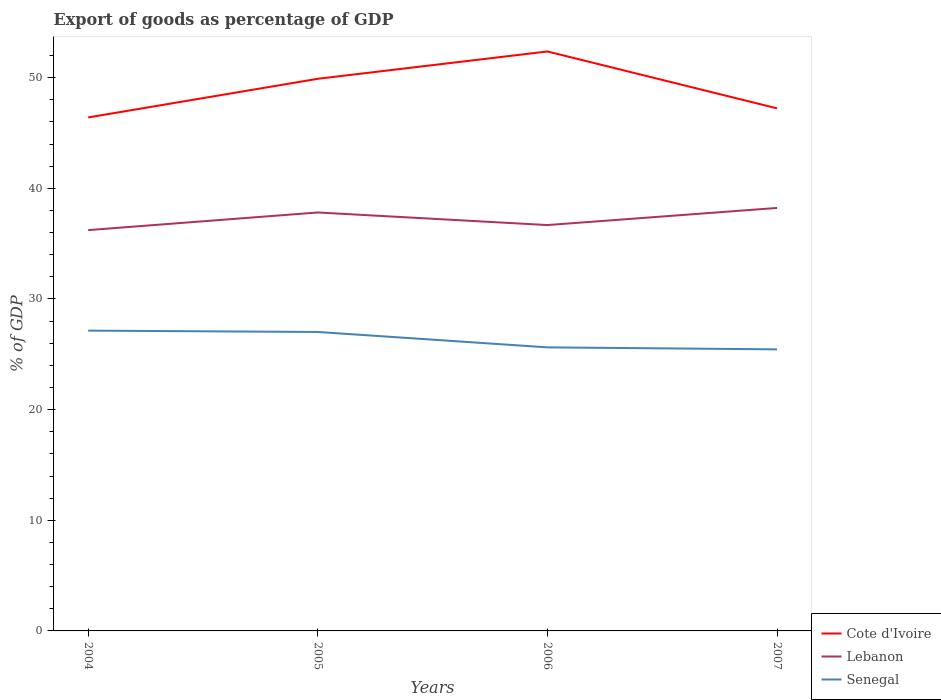Does the line corresponding to Cote d'Ivoire intersect with the line corresponding to Lebanon?
Give a very brief answer. No. Is the number of lines equal to the number of legend labels?
Offer a terse response. Yes. Across all years, what is the maximum export of goods as percentage of GDP in Lebanon?
Make the answer very short. 36.22. What is the total export of goods as percentage of GDP in Senegal in the graph?
Provide a short and direct response. 0.12. What is the difference between the highest and the second highest export of goods as percentage of GDP in Cote d'Ivoire?
Your answer should be very brief. 5.96. What is the difference between the highest and the lowest export of goods as percentage of GDP in Senegal?
Give a very brief answer. 2. Is the export of goods as percentage of GDP in Senegal strictly greater than the export of goods as percentage of GDP in Cote d'Ivoire over the years?
Your response must be concise. Yes. Does the graph contain any zero values?
Provide a short and direct response. No. Where does the legend appear in the graph?
Offer a very short reply. Bottom right. How many legend labels are there?
Make the answer very short. 3. What is the title of the graph?
Your answer should be very brief. Export of goods as percentage of GDP. What is the label or title of the X-axis?
Your answer should be very brief. Years. What is the label or title of the Y-axis?
Provide a short and direct response. % of GDP. What is the % of GDP in Cote d'Ivoire in 2004?
Provide a succinct answer. 46.41. What is the % of GDP of Lebanon in 2004?
Provide a succinct answer. 36.22. What is the % of GDP in Senegal in 2004?
Your answer should be compact. 27.14. What is the % of GDP in Cote d'Ivoire in 2005?
Provide a succinct answer. 49.9. What is the % of GDP in Lebanon in 2005?
Your response must be concise. 37.82. What is the % of GDP in Senegal in 2005?
Keep it short and to the point. 27.02. What is the % of GDP of Cote d'Ivoire in 2006?
Offer a terse response. 52.37. What is the % of GDP in Lebanon in 2006?
Offer a terse response. 36.68. What is the % of GDP in Senegal in 2006?
Offer a terse response. 25.63. What is the % of GDP in Cote d'Ivoire in 2007?
Provide a succinct answer. 47.23. What is the % of GDP of Lebanon in 2007?
Make the answer very short. 38.23. What is the % of GDP in Senegal in 2007?
Your answer should be very brief. 25.45. Across all years, what is the maximum % of GDP in Cote d'Ivoire?
Make the answer very short. 52.37. Across all years, what is the maximum % of GDP in Lebanon?
Provide a short and direct response. 38.23. Across all years, what is the maximum % of GDP in Senegal?
Keep it short and to the point. 27.14. Across all years, what is the minimum % of GDP of Cote d'Ivoire?
Offer a terse response. 46.41. Across all years, what is the minimum % of GDP in Lebanon?
Your answer should be compact. 36.22. Across all years, what is the minimum % of GDP of Senegal?
Your answer should be compact. 25.45. What is the total % of GDP in Cote d'Ivoire in the graph?
Provide a short and direct response. 195.9. What is the total % of GDP of Lebanon in the graph?
Your answer should be compact. 148.95. What is the total % of GDP in Senegal in the graph?
Your response must be concise. 105.23. What is the difference between the % of GDP in Cote d'Ivoire in 2004 and that in 2005?
Ensure brevity in your answer.  -3.49. What is the difference between the % of GDP in Lebanon in 2004 and that in 2005?
Make the answer very short. -1.59. What is the difference between the % of GDP of Senegal in 2004 and that in 2005?
Your answer should be very brief. 0.12. What is the difference between the % of GDP in Cote d'Ivoire in 2004 and that in 2006?
Make the answer very short. -5.96. What is the difference between the % of GDP of Lebanon in 2004 and that in 2006?
Keep it short and to the point. -0.46. What is the difference between the % of GDP of Senegal in 2004 and that in 2006?
Your answer should be very brief. 1.51. What is the difference between the % of GDP in Cote d'Ivoire in 2004 and that in 2007?
Ensure brevity in your answer.  -0.82. What is the difference between the % of GDP of Lebanon in 2004 and that in 2007?
Your response must be concise. -2. What is the difference between the % of GDP of Senegal in 2004 and that in 2007?
Keep it short and to the point. 1.69. What is the difference between the % of GDP in Cote d'Ivoire in 2005 and that in 2006?
Your answer should be compact. -2.47. What is the difference between the % of GDP of Lebanon in 2005 and that in 2006?
Ensure brevity in your answer.  1.14. What is the difference between the % of GDP of Senegal in 2005 and that in 2006?
Your answer should be very brief. 1.39. What is the difference between the % of GDP in Cote d'Ivoire in 2005 and that in 2007?
Provide a short and direct response. 2.67. What is the difference between the % of GDP in Lebanon in 2005 and that in 2007?
Your response must be concise. -0.41. What is the difference between the % of GDP in Senegal in 2005 and that in 2007?
Ensure brevity in your answer.  1.57. What is the difference between the % of GDP in Cote d'Ivoire in 2006 and that in 2007?
Your answer should be compact. 5.14. What is the difference between the % of GDP in Lebanon in 2006 and that in 2007?
Give a very brief answer. -1.55. What is the difference between the % of GDP in Senegal in 2006 and that in 2007?
Keep it short and to the point. 0.18. What is the difference between the % of GDP in Cote d'Ivoire in 2004 and the % of GDP in Lebanon in 2005?
Make the answer very short. 8.59. What is the difference between the % of GDP in Cote d'Ivoire in 2004 and the % of GDP in Senegal in 2005?
Your answer should be very brief. 19.39. What is the difference between the % of GDP in Lebanon in 2004 and the % of GDP in Senegal in 2005?
Ensure brevity in your answer.  9.21. What is the difference between the % of GDP of Cote d'Ivoire in 2004 and the % of GDP of Lebanon in 2006?
Ensure brevity in your answer.  9.73. What is the difference between the % of GDP of Cote d'Ivoire in 2004 and the % of GDP of Senegal in 2006?
Give a very brief answer. 20.78. What is the difference between the % of GDP in Lebanon in 2004 and the % of GDP in Senegal in 2006?
Give a very brief answer. 10.6. What is the difference between the % of GDP in Cote d'Ivoire in 2004 and the % of GDP in Lebanon in 2007?
Your response must be concise. 8.18. What is the difference between the % of GDP of Cote d'Ivoire in 2004 and the % of GDP of Senegal in 2007?
Offer a terse response. 20.96. What is the difference between the % of GDP of Lebanon in 2004 and the % of GDP of Senegal in 2007?
Make the answer very short. 10.78. What is the difference between the % of GDP of Cote d'Ivoire in 2005 and the % of GDP of Lebanon in 2006?
Give a very brief answer. 13.22. What is the difference between the % of GDP in Cote d'Ivoire in 2005 and the % of GDP in Senegal in 2006?
Provide a succinct answer. 24.27. What is the difference between the % of GDP in Lebanon in 2005 and the % of GDP in Senegal in 2006?
Your response must be concise. 12.19. What is the difference between the % of GDP in Cote d'Ivoire in 2005 and the % of GDP in Lebanon in 2007?
Provide a short and direct response. 11.67. What is the difference between the % of GDP of Cote d'Ivoire in 2005 and the % of GDP of Senegal in 2007?
Your response must be concise. 24.45. What is the difference between the % of GDP in Lebanon in 2005 and the % of GDP in Senegal in 2007?
Offer a terse response. 12.37. What is the difference between the % of GDP of Cote d'Ivoire in 2006 and the % of GDP of Lebanon in 2007?
Your answer should be compact. 14.14. What is the difference between the % of GDP in Cote d'Ivoire in 2006 and the % of GDP in Senegal in 2007?
Provide a succinct answer. 26.92. What is the difference between the % of GDP of Lebanon in 2006 and the % of GDP of Senegal in 2007?
Provide a succinct answer. 11.23. What is the average % of GDP in Cote d'Ivoire per year?
Make the answer very short. 48.97. What is the average % of GDP in Lebanon per year?
Offer a terse response. 37.24. What is the average % of GDP of Senegal per year?
Provide a succinct answer. 26.31. In the year 2004, what is the difference between the % of GDP in Cote d'Ivoire and % of GDP in Lebanon?
Keep it short and to the point. 10.18. In the year 2004, what is the difference between the % of GDP in Cote d'Ivoire and % of GDP in Senegal?
Your answer should be compact. 19.27. In the year 2004, what is the difference between the % of GDP of Lebanon and % of GDP of Senegal?
Provide a succinct answer. 9.08. In the year 2005, what is the difference between the % of GDP in Cote d'Ivoire and % of GDP in Lebanon?
Your answer should be very brief. 12.08. In the year 2005, what is the difference between the % of GDP in Cote d'Ivoire and % of GDP in Senegal?
Make the answer very short. 22.88. In the year 2005, what is the difference between the % of GDP of Lebanon and % of GDP of Senegal?
Your answer should be very brief. 10.8. In the year 2006, what is the difference between the % of GDP of Cote d'Ivoire and % of GDP of Lebanon?
Offer a very short reply. 15.69. In the year 2006, what is the difference between the % of GDP in Cote d'Ivoire and % of GDP in Senegal?
Your answer should be very brief. 26.74. In the year 2006, what is the difference between the % of GDP in Lebanon and % of GDP in Senegal?
Provide a succinct answer. 11.05. In the year 2007, what is the difference between the % of GDP in Cote d'Ivoire and % of GDP in Lebanon?
Offer a very short reply. 9. In the year 2007, what is the difference between the % of GDP of Cote d'Ivoire and % of GDP of Senegal?
Provide a succinct answer. 21.78. In the year 2007, what is the difference between the % of GDP in Lebanon and % of GDP in Senegal?
Give a very brief answer. 12.78. What is the ratio of the % of GDP in Lebanon in 2004 to that in 2005?
Provide a short and direct response. 0.96. What is the ratio of the % of GDP in Senegal in 2004 to that in 2005?
Make the answer very short. 1. What is the ratio of the % of GDP in Cote d'Ivoire in 2004 to that in 2006?
Your answer should be very brief. 0.89. What is the ratio of the % of GDP of Lebanon in 2004 to that in 2006?
Provide a succinct answer. 0.99. What is the ratio of the % of GDP of Senegal in 2004 to that in 2006?
Provide a succinct answer. 1.06. What is the ratio of the % of GDP in Cote d'Ivoire in 2004 to that in 2007?
Provide a succinct answer. 0.98. What is the ratio of the % of GDP of Lebanon in 2004 to that in 2007?
Give a very brief answer. 0.95. What is the ratio of the % of GDP in Senegal in 2004 to that in 2007?
Provide a succinct answer. 1.07. What is the ratio of the % of GDP in Cote d'Ivoire in 2005 to that in 2006?
Keep it short and to the point. 0.95. What is the ratio of the % of GDP of Lebanon in 2005 to that in 2006?
Keep it short and to the point. 1.03. What is the ratio of the % of GDP of Senegal in 2005 to that in 2006?
Offer a terse response. 1.05. What is the ratio of the % of GDP in Cote d'Ivoire in 2005 to that in 2007?
Ensure brevity in your answer.  1.06. What is the ratio of the % of GDP in Lebanon in 2005 to that in 2007?
Your answer should be very brief. 0.99. What is the ratio of the % of GDP of Senegal in 2005 to that in 2007?
Offer a terse response. 1.06. What is the ratio of the % of GDP of Cote d'Ivoire in 2006 to that in 2007?
Make the answer very short. 1.11. What is the ratio of the % of GDP of Lebanon in 2006 to that in 2007?
Your response must be concise. 0.96. What is the ratio of the % of GDP in Senegal in 2006 to that in 2007?
Give a very brief answer. 1.01. What is the difference between the highest and the second highest % of GDP of Cote d'Ivoire?
Keep it short and to the point. 2.47. What is the difference between the highest and the second highest % of GDP of Lebanon?
Your response must be concise. 0.41. What is the difference between the highest and the second highest % of GDP of Senegal?
Your response must be concise. 0.12. What is the difference between the highest and the lowest % of GDP in Cote d'Ivoire?
Make the answer very short. 5.96. What is the difference between the highest and the lowest % of GDP of Lebanon?
Offer a very short reply. 2. What is the difference between the highest and the lowest % of GDP of Senegal?
Ensure brevity in your answer.  1.69. 